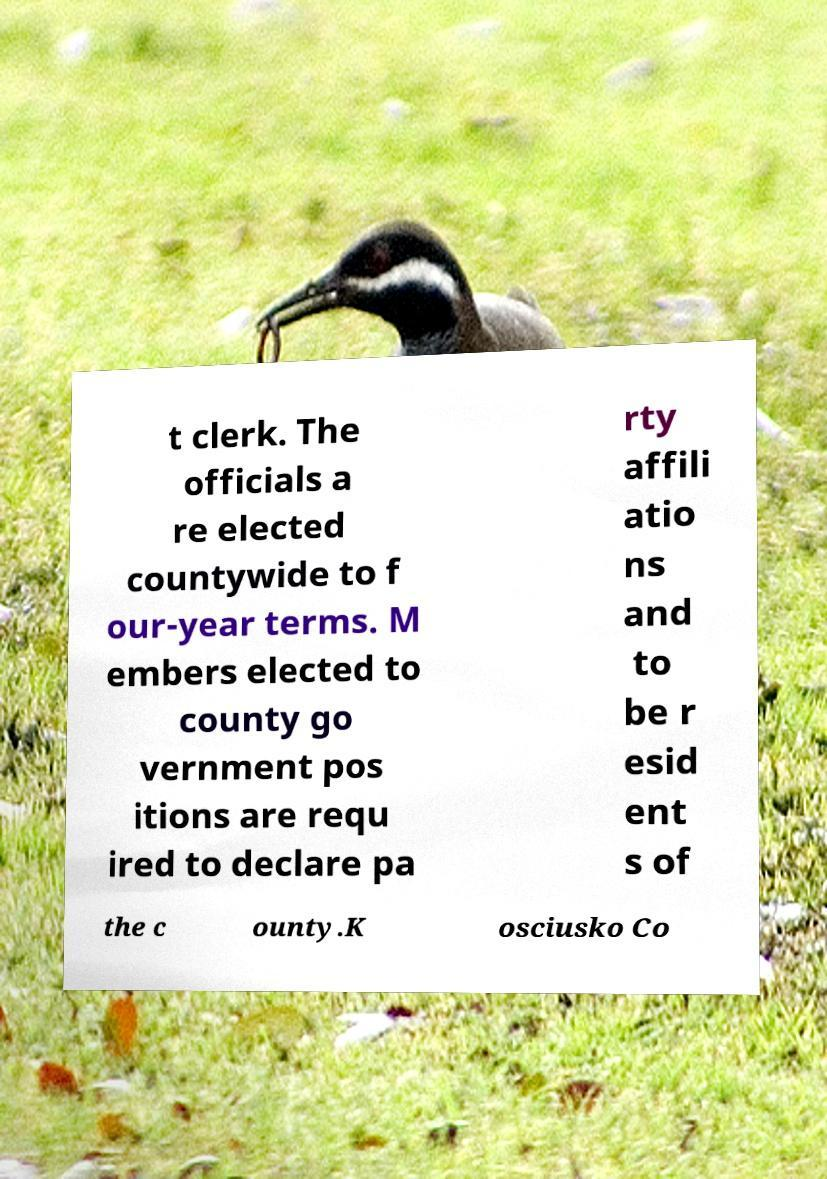Can you accurately transcribe the text from the provided image for me? t clerk. The officials a re elected countywide to f our-year terms. M embers elected to county go vernment pos itions are requ ired to declare pa rty affili atio ns and to be r esid ent s of the c ounty.K osciusko Co 